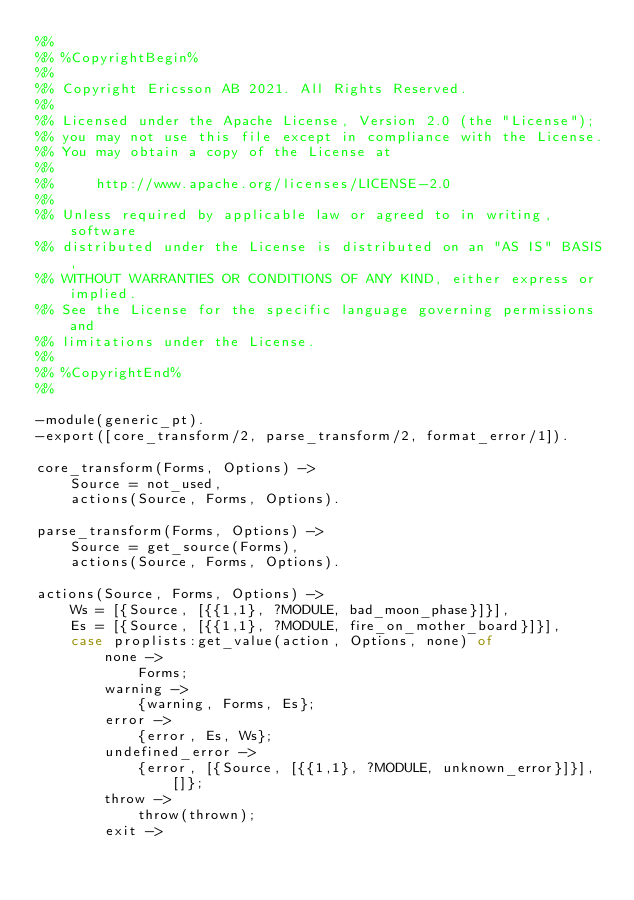<code> <loc_0><loc_0><loc_500><loc_500><_Erlang_>%%
%% %CopyrightBegin%
%%
%% Copyright Ericsson AB 2021. All Rights Reserved.
%%
%% Licensed under the Apache License, Version 2.0 (the "License");
%% you may not use this file except in compliance with the License.
%% You may obtain a copy of the License at
%%
%%     http://www.apache.org/licenses/LICENSE-2.0
%%
%% Unless required by applicable law or agreed to in writing, software
%% distributed under the License is distributed on an "AS IS" BASIS,
%% WITHOUT WARRANTIES OR CONDITIONS OF ANY KIND, either express or implied.
%% See the License for the specific language governing permissions and
%% limitations under the License.
%%
%% %CopyrightEnd%
%%

-module(generic_pt).
-export([core_transform/2, parse_transform/2, format_error/1]).

core_transform(Forms, Options) ->
    Source = not_used,
    actions(Source, Forms, Options).

parse_transform(Forms, Options) ->
    Source = get_source(Forms),
    actions(Source, Forms, Options).

actions(Source, Forms, Options) ->
    Ws = [{Source, [{{1,1}, ?MODULE, bad_moon_phase}]}],
    Es = [{Source, [{{1,1}, ?MODULE, fire_on_mother_board}]}],
    case proplists:get_value(action, Options, none) of
        none ->
            Forms;
        warning ->
            {warning, Forms, Es};
        error ->
            {error, Es, Ws};
        undefined_error ->
            {error, [{Source, [{{1,1}, ?MODULE, unknown_error}]}], []};
        throw ->
            throw(thrown);
        exit -></code> 